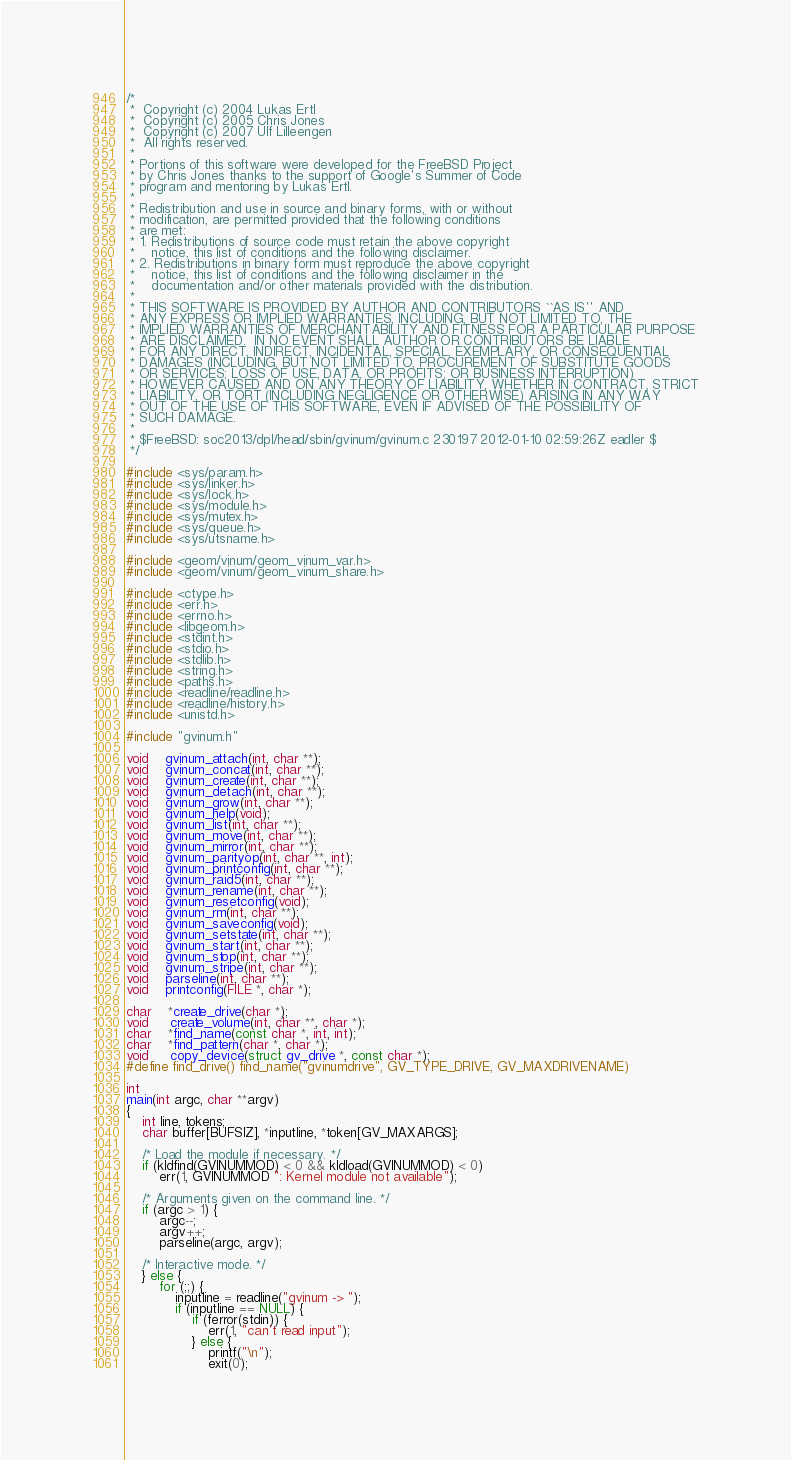<code> <loc_0><loc_0><loc_500><loc_500><_C_>/*
 *  Copyright (c) 2004 Lukas Ertl
 *  Copyright (c) 2005 Chris Jones
 *  Copyright (c) 2007 Ulf Lilleengen
 *  All rights reserved.
 *
 * Portions of this software were developed for the FreeBSD Project
 * by Chris Jones thanks to the support of Google's Summer of Code
 * program and mentoring by Lukas Ertl.
 *
 * Redistribution and use in source and binary forms, with or without
 * modification, are permitted provided that the following conditions
 * are met:
 * 1. Redistributions of source code must retain the above copyright
 *    notice, this list of conditions and the following disclaimer.
 * 2. Redistributions in binary form must reproduce the above copyright
 *    notice, this list of conditions and the following disclaimer in the
 *    documentation and/or other materials provided with the distribution.
 *
 * THIS SOFTWARE IS PROVIDED BY AUTHOR AND CONTRIBUTORS ``AS IS'' AND
 * ANY EXPRESS OR IMPLIED WARRANTIES, INCLUDING, BUT NOT LIMITED TO, THE
 * IMPLIED WARRANTIES OF MERCHANTABILITY AND FITNESS FOR A PARTICULAR PURPOSE
 * ARE DISCLAIMED.  IN NO EVENT SHALL AUTHOR OR CONTRIBUTORS BE LIABLE
 * FOR ANY DIRECT, INDIRECT, INCIDENTAL, SPECIAL, EXEMPLARY, OR CONSEQUENTIAL
 * DAMAGES (INCLUDING, BUT NOT LIMITED TO, PROCUREMENT OF SUBSTITUTE GOODS
 * OR SERVICES; LOSS OF USE, DATA, OR PROFITS; OR BUSINESS INTERRUPTION)
 * HOWEVER CAUSED AND ON ANY THEORY OF LIABILITY, WHETHER IN CONTRACT, STRICT
 * LIABILITY, OR TORT (INCLUDING NEGLIGENCE OR OTHERWISE) ARISING IN ANY WAY
 * OUT OF THE USE OF THIS SOFTWARE, EVEN IF ADVISED OF THE POSSIBILITY OF
 * SUCH DAMAGE.
 *
 * $FreeBSD: soc2013/dpl/head/sbin/gvinum/gvinum.c 230197 2012-01-10 02:59:26Z eadler $
 */

#include <sys/param.h>
#include <sys/linker.h>
#include <sys/lock.h>
#include <sys/module.h>
#include <sys/mutex.h>
#include <sys/queue.h>
#include <sys/utsname.h>

#include <geom/vinum/geom_vinum_var.h>
#include <geom/vinum/geom_vinum_share.h>

#include <ctype.h>
#include <err.h>
#include <errno.h>
#include <libgeom.h>
#include <stdint.h>
#include <stdio.h>
#include <stdlib.h>
#include <string.h>
#include <paths.h>
#include <readline/readline.h>
#include <readline/history.h>
#include <unistd.h>

#include "gvinum.h"

void	gvinum_attach(int, char **);
void	gvinum_concat(int, char **);
void	gvinum_create(int, char **);
void	gvinum_detach(int, char **);
void	gvinum_grow(int, char **);
void	gvinum_help(void);
void	gvinum_list(int, char **);
void	gvinum_move(int, char **);
void	gvinum_mirror(int, char **);
void	gvinum_parityop(int, char **, int);
void	gvinum_printconfig(int, char **);
void	gvinum_raid5(int, char **);
void	gvinum_rename(int, char **);
void	gvinum_resetconfig(void);
void	gvinum_rm(int, char **);
void	gvinum_saveconfig(void);
void	gvinum_setstate(int, char **);
void	gvinum_start(int, char **);
void	gvinum_stop(int, char **);
void	gvinum_stripe(int, char **);
void	parseline(int, char **);
void	printconfig(FILE *, char *);

char	*create_drive(char *);
void	 create_volume(int, char **, char *);
char	*find_name(const char *, int, int);
char	*find_pattern(char *, char *);
void	 copy_device(struct gv_drive *, const char *);
#define find_drive() find_name("gvinumdrive", GV_TYPE_DRIVE, GV_MAXDRIVENAME)

int
main(int argc, char **argv)
{
	int line, tokens;
	char buffer[BUFSIZ], *inputline, *token[GV_MAXARGS];

	/* Load the module if necessary. */
	if (kldfind(GVINUMMOD) < 0 && kldload(GVINUMMOD) < 0)
		err(1, GVINUMMOD ": Kernel module not available");

	/* Arguments given on the command line. */
	if (argc > 1) {
		argc--;
		argv++;
		parseline(argc, argv);

	/* Interactive mode. */
	} else {
		for (;;) {
			inputline = readline("gvinum -> ");
			if (inputline == NULL) {
				if (ferror(stdin)) {
					err(1, "can't read input");
				} else {
					printf("\n");
					exit(0);</code> 